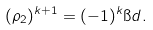<formula> <loc_0><loc_0><loc_500><loc_500>( \rho _ { 2 } ) ^ { k + 1 } = ( - 1 ) ^ { k } \i d .</formula> 